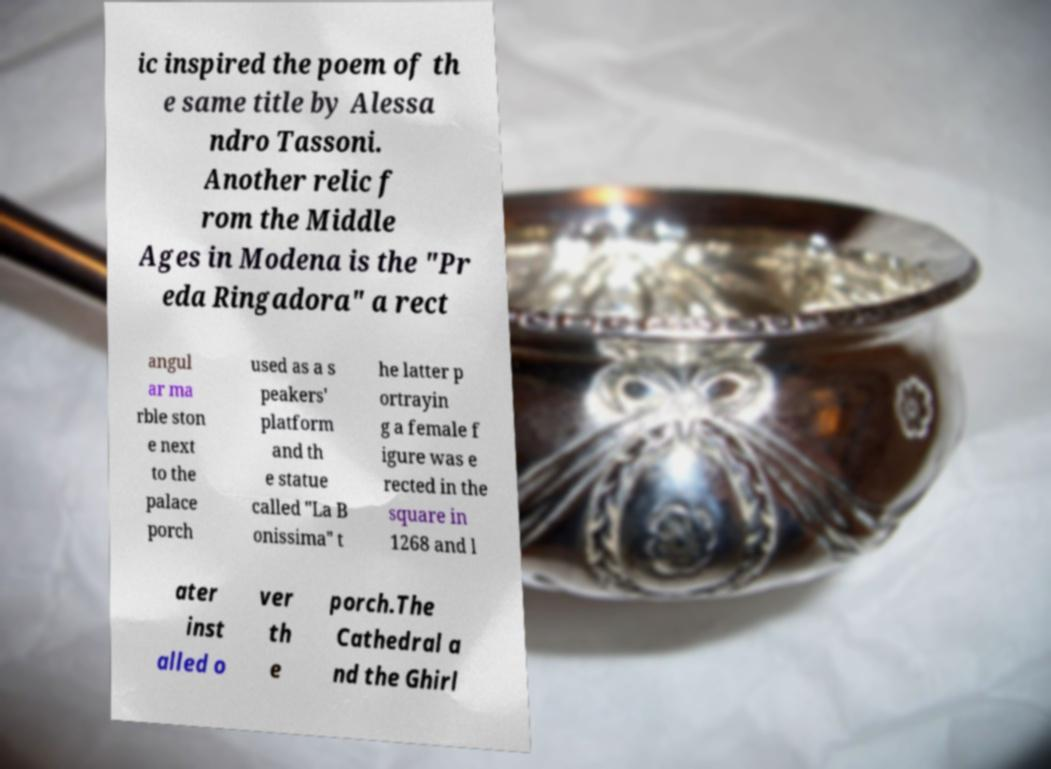Could you extract and type out the text from this image? ic inspired the poem of th e same title by Alessa ndro Tassoni. Another relic f rom the Middle Ages in Modena is the "Pr eda Ringadora" a rect angul ar ma rble ston e next to the palace porch used as a s peakers' platform and th e statue called "La B onissima" t he latter p ortrayin g a female f igure was e rected in the square in 1268 and l ater inst alled o ver th e porch.The Cathedral a nd the Ghirl 